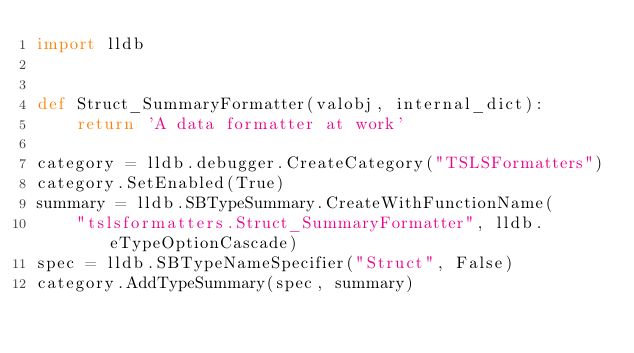Convert code to text. <code><loc_0><loc_0><loc_500><loc_500><_Python_>import lldb


def Struct_SummaryFormatter(valobj, internal_dict):
    return 'A data formatter at work'

category = lldb.debugger.CreateCategory("TSLSFormatters")
category.SetEnabled(True)
summary = lldb.SBTypeSummary.CreateWithFunctionName(
    "tslsformatters.Struct_SummaryFormatter", lldb.eTypeOptionCascade)
spec = lldb.SBTypeNameSpecifier("Struct", False)
category.AddTypeSummary(spec, summary)
</code> 